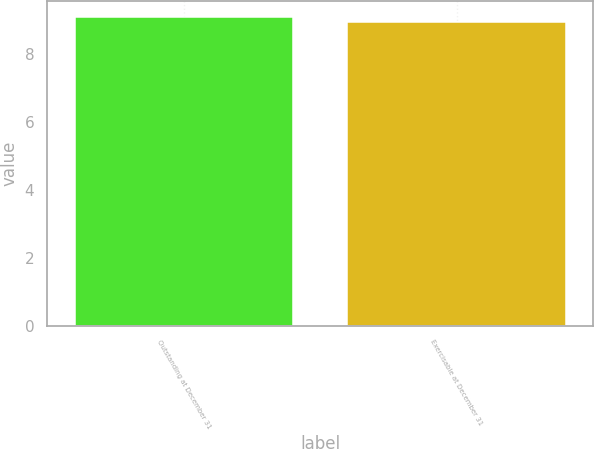Convert chart to OTSL. <chart><loc_0><loc_0><loc_500><loc_500><bar_chart><fcel>Outstanding at December 31<fcel>Exercisable at December 31<nl><fcel>9.09<fcel>8.95<nl></chart> 